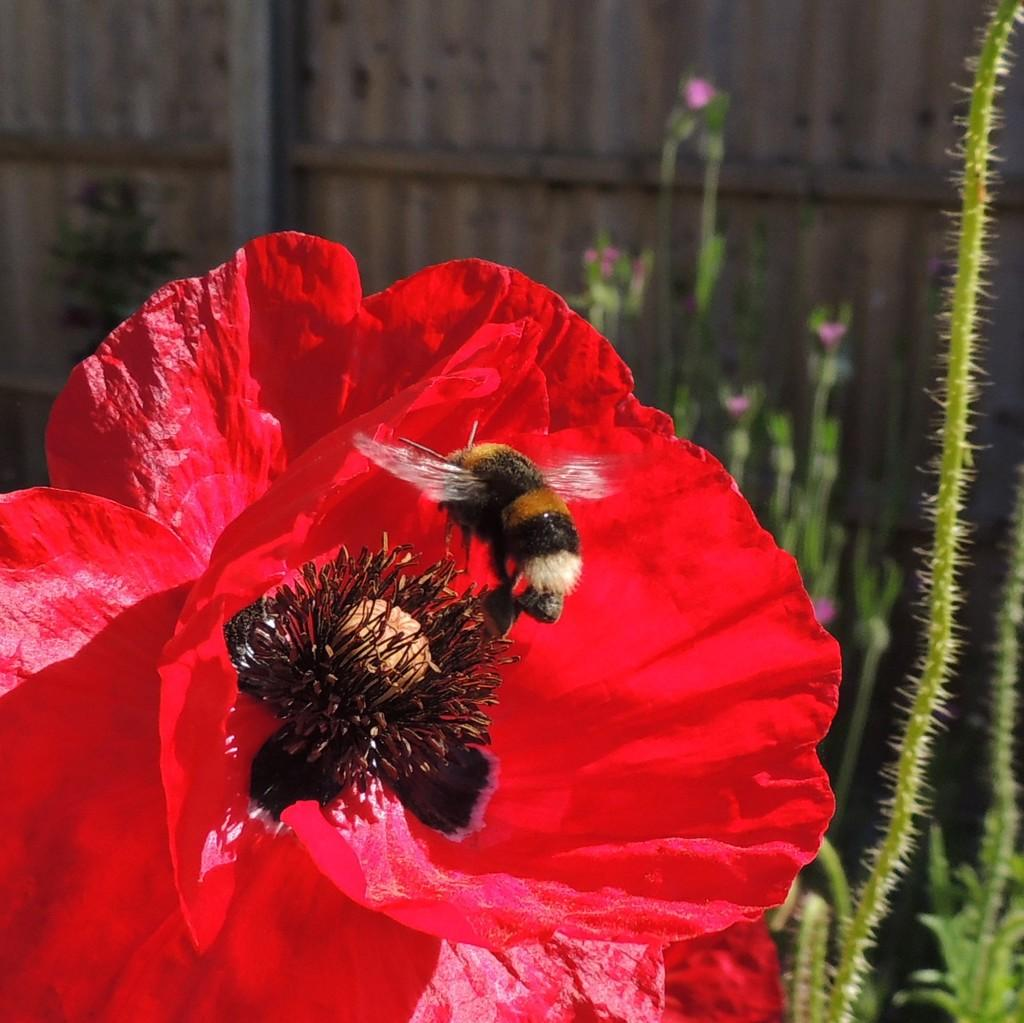What is on the flower in the image? There is a fly on a flower in the image. What can be seen in the background of the image? There are plants and a wall in the background of the image. What type of payment is being made by the kitty in the image? There is no kitty present in the image, and therefore no payment can be made. 